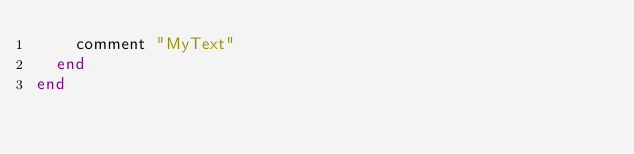<code> <loc_0><loc_0><loc_500><loc_500><_Ruby_>    comment "MyText"
  end
end
</code> 